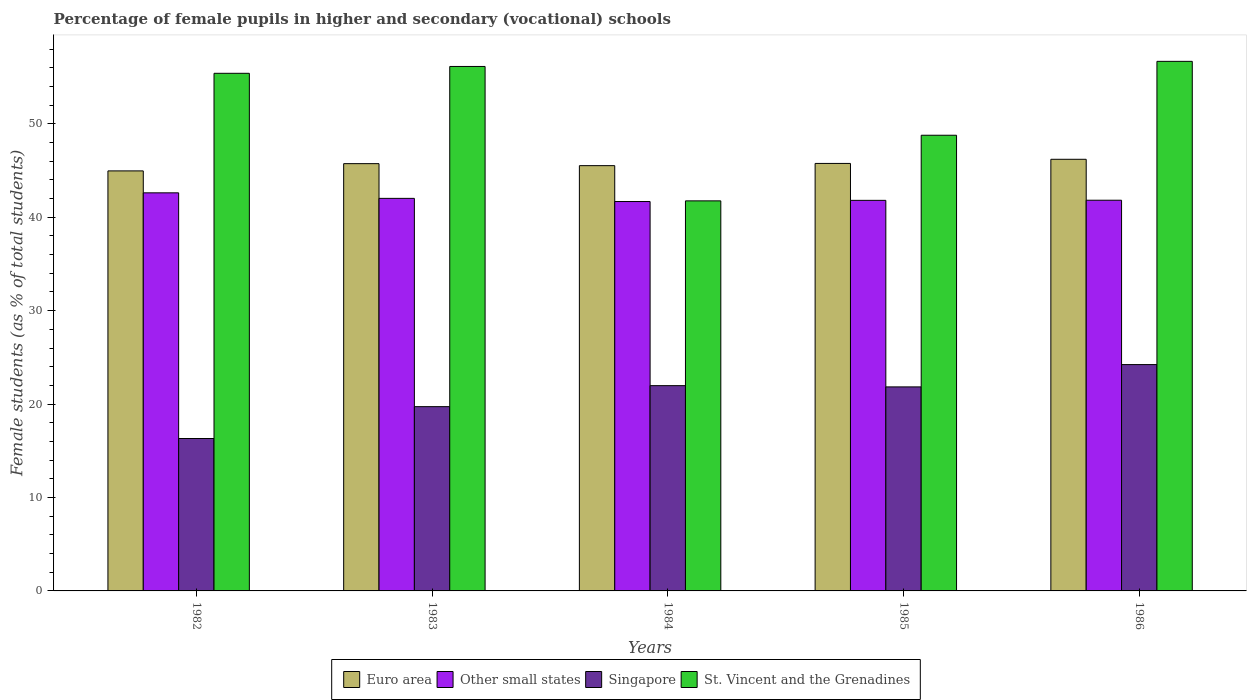How many groups of bars are there?
Your answer should be compact. 5. Are the number of bars on each tick of the X-axis equal?
Offer a terse response. Yes. How many bars are there on the 4th tick from the right?
Give a very brief answer. 4. What is the label of the 1st group of bars from the left?
Make the answer very short. 1982. In how many cases, is the number of bars for a given year not equal to the number of legend labels?
Your answer should be very brief. 0. What is the percentage of female pupils in higher and secondary schools in Singapore in 1982?
Offer a very short reply. 16.31. Across all years, what is the maximum percentage of female pupils in higher and secondary schools in Other small states?
Offer a very short reply. 42.61. Across all years, what is the minimum percentage of female pupils in higher and secondary schools in Singapore?
Your answer should be very brief. 16.31. What is the total percentage of female pupils in higher and secondary schools in Euro area in the graph?
Offer a very short reply. 228.16. What is the difference between the percentage of female pupils in higher and secondary schools in St. Vincent and the Grenadines in 1982 and that in 1986?
Make the answer very short. -1.28. What is the difference between the percentage of female pupils in higher and secondary schools in St. Vincent and the Grenadines in 1985 and the percentage of female pupils in higher and secondary schools in Singapore in 1984?
Offer a very short reply. 26.8. What is the average percentage of female pupils in higher and secondary schools in St. Vincent and the Grenadines per year?
Provide a succinct answer. 51.75. In the year 1984, what is the difference between the percentage of female pupils in higher and secondary schools in Euro area and percentage of female pupils in higher and secondary schools in Other small states?
Your answer should be compact. 3.84. In how many years, is the percentage of female pupils in higher and secondary schools in Other small states greater than 22 %?
Keep it short and to the point. 5. What is the ratio of the percentage of female pupils in higher and secondary schools in Singapore in 1984 to that in 1985?
Offer a terse response. 1.01. What is the difference between the highest and the second highest percentage of female pupils in higher and secondary schools in Singapore?
Provide a short and direct response. 2.26. What is the difference between the highest and the lowest percentage of female pupils in higher and secondary schools in St. Vincent and the Grenadines?
Provide a short and direct response. 14.93. In how many years, is the percentage of female pupils in higher and secondary schools in St. Vincent and the Grenadines greater than the average percentage of female pupils in higher and secondary schools in St. Vincent and the Grenadines taken over all years?
Offer a very short reply. 3. Is it the case that in every year, the sum of the percentage of female pupils in higher and secondary schools in Other small states and percentage of female pupils in higher and secondary schools in Euro area is greater than the sum of percentage of female pupils in higher and secondary schools in St. Vincent and the Grenadines and percentage of female pupils in higher and secondary schools in Singapore?
Offer a very short reply. Yes. What does the 3rd bar from the left in 1986 represents?
Keep it short and to the point. Singapore. Is it the case that in every year, the sum of the percentage of female pupils in higher and secondary schools in St. Vincent and the Grenadines and percentage of female pupils in higher and secondary schools in Other small states is greater than the percentage of female pupils in higher and secondary schools in Singapore?
Offer a very short reply. Yes. How many bars are there?
Your response must be concise. 20. Are all the bars in the graph horizontal?
Give a very brief answer. No. Does the graph contain grids?
Keep it short and to the point. No. Where does the legend appear in the graph?
Your answer should be compact. Bottom center. How are the legend labels stacked?
Ensure brevity in your answer.  Horizontal. What is the title of the graph?
Provide a short and direct response. Percentage of female pupils in higher and secondary (vocational) schools. What is the label or title of the X-axis?
Make the answer very short. Years. What is the label or title of the Y-axis?
Give a very brief answer. Female students (as % of total students). What is the Female students (as % of total students) of Euro area in 1982?
Make the answer very short. 44.96. What is the Female students (as % of total students) in Other small states in 1982?
Provide a succinct answer. 42.61. What is the Female students (as % of total students) of Singapore in 1982?
Your answer should be compact. 16.31. What is the Female students (as % of total students) in St. Vincent and the Grenadines in 1982?
Ensure brevity in your answer.  55.4. What is the Female students (as % of total students) in Euro area in 1983?
Provide a short and direct response. 45.73. What is the Female students (as % of total students) in Other small states in 1983?
Ensure brevity in your answer.  42.02. What is the Female students (as % of total students) of Singapore in 1983?
Provide a short and direct response. 19.72. What is the Female students (as % of total students) of St. Vincent and the Grenadines in 1983?
Your response must be concise. 56.13. What is the Female students (as % of total students) of Euro area in 1984?
Provide a short and direct response. 45.52. What is the Female students (as % of total students) in Other small states in 1984?
Provide a short and direct response. 41.68. What is the Female students (as % of total students) in Singapore in 1984?
Keep it short and to the point. 21.97. What is the Female students (as % of total students) of St. Vincent and the Grenadines in 1984?
Your answer should be very brief. 41.75. What is the Female students (as % of total students) in Euro area in 1985?
Offer a terse response. 45.76. What is the Female students (as % of total students) in Other small states in 1985?
Give a very brief answer. 41.8. What is the Female students (as % of total students) in Singapore in 1985?
Provide a succinct answer. 21.84. What is the Female students (as % of total students) in St. Vincent and the Grenadines in 1985?
Your answer should be very brief. 48.77. What is the Female students (as % of total students) in Euro area in 1986?
Your answer should be compact. 46.2. What is the Female students (as % of total students) in Other small states in 1986?
Your answer should be very brief. 41.82. What is the Female students (as % of total students) of Singapore in 1986?
Your answer should be very brief. 24.23. What is the Female students (as % of total students) of St. Vincent and the Grenadines in 1986?
Keep it short and to the point. 56.68. Across all years, what is the maximum Female students (as % of total students) in Euro area?
Your answer should be compact. 46.2. Across all years, what is the maximum Female students (as % of total students) of Other small states?
Offer a terse response. 42.61. Across all years, what is the maximum Female students (as % of total students) of Singapore?
Give a very brief answer. 24.23. Across all years, what is the maximum Female students (as % of total students) in St. Vincent and the Grenadines?
Provide a short and direct response. 56.68. Across all years, what is the minimum Female students (as % of total students) of Euro area?
Your response must be concise. 44.96. Across all years, what is the minimum Female students (as % of total students) in Other small states?
Your response must be concise. 41.68. Across all years, what is the minimum Female students (as % of total students) in Singapore?
Offer a very short reply. 16.31. Across all years, what is the minimum Female students (as % of total students) in St. Vincent and the Grenadines?
Your answer should be very brief. 41.75. What is the total Female students (as % of total students) of Euro area in the graph?
Keep it short and to the point. 228.16. What is the total Female students (as % of total students) in Other small states in the graph?
Offer a very short reply. 209.92. What is the total Female students (as % of total students) of Singapore in the graph?
Provide a succinct answer. 104.07. What is the total Female students (as % of total students) of St. Vincent and the Grenadines in the graph?
Your answer should be very brief. 258.73. What is the difference between the Female students (as % of total students) in Euro area in 1982 and that in 1983?
Offer a very short reply. -0.78. What is the difference between the Female students (as % of total students) in Other small states in 1982 and that in 1983?
Keep it short and to the point. 0.59. What is the difference between the Female students (as % of total students) of Singapore in 1982 and that in 1983?
Your response must be concise. -3.41. What is the difference between the Female students (as % of total students) of St. Vincent and the Grenadines in 1982 and that in 1983?
Make the answer very short. -0.73. What is the difference between the Female students (as % of total students) in Euro area in 1982 and that in 1984?
Your answer should be compact. -0.56. What is the difference between the Female students (as % of total students) in Other small states in 1982 and that in 1984?
Your answer should be compact. 0.93. What is the difference between the Female students (as % of total students) of Singapore in 1982 and that in 1984?
Your answer should be very brief. -5.66. What is the difference between the Female students (as % of total students) of St. Vincent and the Grenadines in 1982 and that in 1984?
Make the answer very short. 13.65. What is the difference between the Female students (as % of total students) in Euro area in 1982 and that in 1985?
Offer a terse response. -0.8. What is the difference between the Female students (as % of total students) in Other small states in 1982 and that in 1985?
Provide a succinct answer. 0.8. What is the difference between the Female students (as % of total students) in Singapore in 1982 and that in 1985?
Keep it short and to the point. -5.52. What is the difference between the Female students (as % of total students) of St. Vincent and the Grenadines in 1982 and that in 1985?
Your answer should be very brief. 6.63. What is the difference between the Female students (as % of total students) of Euro area in 1982 and that in 1986?
Your answer should be compact. -1.24. What is the difference between the Female students (as % of total students) of Other small states in 1982 and that in 1986?
Offer a very short reply. 0.79. What is the difference between the Female students (as % of total students) of Singapore in 1982 and that in 1986?
Offer a terse response. -7.91. What is the difference between the Female students (as % of total students) of St. Vincent and the Grenadines in 1982 and that in 1986?
Your answer should be very brief. -1.28. What is the difference between the Female students (as % of total students) of Euro area in 1983 and that in 1984?
Your response must be concise. 0.21. What is the difference between the Female students (as % of total students) in Other small states in 1983 and that in 1984?
Your answer should be very brief. 0.34. What is the difference between the Female students (as % of total students) in Singapore in 1983 and that in 1984?
Offer a terse response. -2.25. What is the difference between the Female students (as % of total students) in St. Vincent and the Grenadines in 1983 and that in 1984?
Make the answer very short. 14.39. What is the difference between the Female students (as % of total students) of Euro area in 1983 and that in 1985?
Offer a very short reply. -0.02. What is the difference between the Female students (as % of total students) of Other small states in 1983 and that in 1985?
Offer a very short reply. 0.21. What is the difference between the Female students (as % of total students) in Singapore in 1983 and that in 1985?
Offer a very short reply. -2.11. What is the difference between the Female students (as % of total students) in St. Vincent and the Grenadines in 1983 and that in 1985?
Your response must be concise. 7.36. What is the difference between the Female students (as % of total students) in Euro area in 1983 and that in 1986?
Provide a short and direct response. -0.47. What is the difference between the Female students (as % of total students) in Other small states in 1983 and that in 1986?
Your answer should be very brief. 0.2. What is the difference between the Female students (as % of total students) of Singapore in 1983 and that in 1986?
Offer a terse response. -4.5. What is the difference between the Female students (as % of total students) of St. Vincent and the Grenadines in 1983 and that in 1986?
Ensure brevity in your answer.  -0.55. What is the difference between the Female students (as % of total students) in Euro area in 1984 and that in 1985?
Offer a terse response. -0.24. What is the difference between the Female students (as % of total students) of Other small states in 1984 and that in 1985?
Make the answer very short. -0.13. What is the difference between the Female students (as % of total students) of Singapore in 1984 and that in 1985?
Give a very brief answer. 0.13. What is the difference between the Female students (as % of total students) of St. Vincent and the Grenadines in 1984 and that in 1985?
Ensure brevity in your answer.  -7.02. What is the difference between the Female students (as % of total students) of Euro area in 1984 and that in 1986?
Your response must be concise. -0.68. What is the difference between the Female students (as % of total students) in Other small states in 1984 and that in 1986?
Your answer should be compact. -0.14. What is the difference between the Female students (as % of total students) of Singapore in 1984 and that in 1986?
Your answer should be very brief. -2.26. What is the difference between the Female students (as % of total students) of St. Vincent and the Grenadines in 1984 and that in 1986?
Offer a very short reply. -14.93. What is the difference between the Female students (as % of total students) of Euro area in 1985 and that in 1986?
Make the answer very short. -0.44. What is the difference between the Female students (as % of total students) in Other small states in 1985 and that in 1986?
Your answer should be compact. -0.01. What is the difference between the Female students (as % of total students) of Singapore in 1985 and that in 1986?
Offer a very short reply. -2.39. What is the difference between the Female students (as % of total students) in St. Vincent and the Grenadines in 1985 and that in 1986?
Ensure brevity in your answer.  -7.91. What is the difference between the Female students (as % of total students) in Euro area in 1982 and the Female students (as % of total students) in Other small states in 1983?
Provide a short and direct response. 2.94. What is the difference between the Female students (as % of total students) of Euro area in 1982 and the Female students (as % of total students) of Singapore in 1983?
Your answer should be compact. 25.23. What is the difference between the Female students (as % of total students) in Euro area in 1982 and the Female students (as % of total students) in St. Vincent and the Grenadines in 1983?
Provide a succinct answer. -11.18. What is the difference between the Female students (as % of total students) in Other small states in 1982 and the Female students (as % of total students) in Singapore in 1983?
Make the answer very short. 22.88. What is the difference between the Female students (as % of total students) of Other small states in 1982 and the Female students (as % of total students) of St. Vincent and the Grenadines in 1983?
Offer a terse response. -13.53. What is the difference between the Female students (as % of total students) of Singapore in 1982 and the Female students (as % of total students) of St. Vincent and the Grenadines in 1983?
Make the answer very short. -39.82. What is the difference between the Female students (as % of total students) of Euro area in 1982 and the Female students (as % of total students) of Other small states in 1984?
Provide a succinct answer. 3.28. What is the difference between the Female students (as % of total students) in Euro area in 1982 and the Female students (as % of total students) in Singapore in 1984?
Keep it short and to the point. 22.99. What is the difference between the Female students (as % of total students) of Euro area in 1982 and the Female students (as % of total students) of St. Vincent and the Grenadines in 1984?
Your answer should be very brief. 3.21. What is the difference between the Female students (as % of total students) of Other small states in 1982 and the Female students (as % of total students) of Singapore in 1984?
Make the answer very short. 20.64. What is the difference between the Female students (as % of total students) in Other small states in 1982 and the Female students (as % of total students) in St. Vincent and the Grenadines in 1984?
Offer a very short reply. 0.86. What is the difference between the Female students (as % of total students) of Singapore in 1982 and the Female students (as % of total students) of St. Vincent and the Grenadines in 1984?
Provide a succinct answer. -25.43. What is the difference between the Female students (as % of total students) of Euro area in 1982 and the Female students (as % of total students) of Other small states in 1985?
Your answer should be very brief. 3.15. What is the difference between the Female students (as % of total students) of Euro area in 1982 and the Female students (as % of total students) of Singapore in 1985?
Provide a succinct answer. 23.12. What is the difference between the Female students (as % of total students) of Euro area in 1982 and the Female students (as % of total students) of St. Vincent and the Grenadines in 1985?
Make the answer very short. -3.82. What is the difference between the Female students (as % of total students) in Other small states in 1982 and the Female students (as % of total students) in Singapore in 1985?
Your response must be concise. 20.77. What is the difference between the Female students (as % of total students) of Other small states in 1982 and the Female students (as % of total students) of St. Vincent and the Grenadines in 1985?
Your answer should be compact. -6.16. What is the difference between the Female students (as % of total students) of Singapore in 1982 and the Female students (as % of total students) of St. Vincent and the Grenadines in 1985?
Offer a very short reply. -32.46. What is the difference between the Female students (as % of total students) in Euro area in 1982 and the Female students (as % of total students) in Other small states in 1986?
Your answer should be very brief. 3.14. What is the difference between the Female students (as % of total students) in Euro area in 1982 and the Female students (as % of total students) in Singapore in 1986?
Provide a short and direct response. 20.73. What is the difference between the Female students (as % of total students) of Euro area in 1982 and the Female students (as % of total students) of St. Vincent and the Grenadines in 1986?
Offer a very short reply. -11.72. What is the difference between the Female students (as % of total students) of Other small states in 1982 and the Female students (as % of total students) of Singapore in 1986?
Your response must be concise. 18.38. What is the difference between the Female students (as % of total students) in Other small states in 1982 and the Female students (as % of total students) in St. Vincent and the Grenadines in 1986?
Provide a short and direct response. -14.07. What is the difference between the Female students (as % of total students) in Singapore in 1982 and the Female students (as % of total students) in St. Vincent and the Grenadines in 1986?
Your response must be concise. -40.37. What is the difference between the Female students (as % of total students) in Euro area in 1983 and the Female students (as % of total students) in Other small states in 1984?
Provide a succinct answer. 4.05. What is the difference between the Female students (as % of total students) in Euro area in 1983 and the Female students (as % of total students) in Singapore in 1984?
Your response must be concise. 23.76. What is the difference between the Female students (as % of total students) of Euro area in 1983 and the Female students (as % of total students) of St. Vincent and the Grenadines in 1984?
Your answer should be very brief. 3.98. What is the difference between the Female students (as % of total students) of Other small states in 1983 and the Female students (as % of total students) of Singapore in 1984?
Your answer should be compact. 20.05. What is the difference between the Female students (as % of total students) in Other small states in 1983 and the Female students (as % of total students) in St. Vincent and the Grenadines in 1984?
Offer a terse response. 0.27. What is the difference between the Female students (as % of total students) in Singapore in 1983 and the Female students (as % of total students) in St. Vincent and the Grenadines in 1984?
Ensure brevity in your answer.  -22.02. What is the difference between the Female students (as % of total students) in Euro area in 1983 and the Female students (as % of total students) in Other small states in 1985?
Your answer should be very brief. 3.93. What is the difference between the Female students (as % of total students) of Euro area in 1983 and the Female students (as % of total students) of Singapore in 1985?
Keep it short and to the point. 23.89. What is the difference between the Female students (as % of total students) in Euro area in 1983 and the Female students (as % of total students) in St. Vincent and the Grenadines in 1985?
Provide a succinct answer. -3.04. What is the difference between the Female students (as % of total students) of Other small states in 1983 and the Female students (as % of total students) of Singapore in 1985?
Provide a succinct answer. 20.18. What is the difference between the Female students (as % of total students) in Other small states in 1983 and the Female students (as % of total students) in St. Vincent and the Grenadines in 1985?
Give a very brief answer. -6.76. What is the difference between the Female students (as % of total students) in Singapore in 1983 and the Female students (as % of total students) in St. Vincent and the Grenadines in 1985?
Give a very brief answer. -29.05. What is the difference between the Female students (as % of total students) of Euro area in 1983 and the Female students (as % of total students) of Other small states in 1986?
Provide a short and direct response. 3.92. What is the difference between the Female students (as % of total students) in Euro area in 1983 and the Female students (as % of total students) in Singapore in 1986?
Keep it short and to the point. 21.51. What is the difference between the Female students (as % of total students) in Euro area in 1983 and the Female students (as % of total students) in St. Vincent and the Grenadines in 1986?
Offer a terse response. -10.95. What is the difference between the Female students (as % of total students) in Other small states in 1983 and the Female students (as % of total students) in Singapore in 1986?
Offer a terse response. 17.79. What is the difference between the Female students (as % of total students) of Other small states in 1983 and the Female students (as % of total students) of St. Vincent and the Grenadines in 1986?
Your response must be concise. -14.66. What is the difference between the Female students (as % of total students) of Singapore in 1983 and the Female students (as % of total students) of St. Vincent and the Grenadines in 1986?
Give a very brief answer. -36.96. What is the difference between the Female students (as % of total students) in Euro area in 1984 and the Female students (as % of total students) in Other small states in 1985?
Provide a succinct answer. 3.71. What is the difference between the Female students (as % of total students) of Euro area in 1984 and the Female students (as % of total students) of Singapore in 1985?
Your answer should be compact. 23.68. What is the difference between the Female students (as % of total students) in Euro area in 1984 and the Female students (as % of total students) in St. Vincent and the Grenadines in 1985?
Offer a terse response. -3.25. What is the difference between the Female students (as % of total students) of Other small states in 1984 and the Female students (as % of total students) of Singapore in 1985?
Your answer should be compact. 19.84. What is the difference between the Female students (as % of total students) of Other small states in 1984 and the Female students (as % of total students) of St. Vincent and the Grenadines in 1985?
Your response must be concise. -7.09. What is the difference between the Female students (as % of total students) of Singapore in 1984 and the Female students (as % of total students) of St. Vincent and the Grenadines in 1985?
Offer a terse response. -26.8. What is the difference between the Female students (as % of total students) of Euro area in 1984 and the Female students (as % of total students) of Other small states in 1986?
Offer a terse response. 3.7. What is the difference between the Female students (as % of total students) of Euro area in 1984 and the Female students (as % of total students) of Singapore in 1986?
Your response must be concise. 21.29. What is the difference between the Female students (as % of total students) of Euro area in 1984 and the Female students (as % of total students) of St. Vincent and the Grenadines in 1986?
Provide a succinct answer. -11.16. What is the difference between the Female students (as % of total students) in Other small states in 1984 and the Female students (as % of total students) in Singapore in 1986?
Give a very brief answer. 17.45. What is the difference between the Female students (as % of total students) in Other small states in 1984 and the Female students (as % of total students) in St. Vincent and the Grenadines in 1986?
Give a very brief answer. -15. What is the difference between the Female students (as % of total students) of Singapore in 1984 and the Female students (as % of total students) of St. Vincent and the Grenadines in 1986?
Keep it short and to the point. -34.71. What is the difference between the Female students (as % of total students) of Euro area in 1985 and the Female students (as % of total students) of Other small states in 1986?
Provide a succinct answer. 3.94. What is the difference between the Female students (as % of total students) of Euro area in 1985 and the Female students (as % of total students) of Singapore in 1986?
Make the answer very short. 21.53. What is the difference between the Female students (as % of total students) of Euro area in 1985 and the Female students (as % of total students) of St. Vincent and the Grenadines in 1986?
Your answer should be compact. -10.92. What is the difference between the Female students (as % of total students) in Other small states in 1985 and the Female students (as % of total students) in Singapore in 1986?
Your response must be concise. 17.58. What is the difference between the Female students (as % of total students) in Other small states in 1985 and the Female students (as % of total students) in St. Vincent and the Grenadines in 1986?
Offer a very short reply. -14.88. What is the difference between the Female students (as % of total students) in Singapore in 1985 and the Female students (as % of total students) in St. Vincent and the Grenadines in 1986?
Keep it short and to the point. -34.84. What is the average Female students (as % of total students) of Euro area per year?
Keep it short and to the point. 45.63. What is the average Female students (as % of total students) of Other small states per year?
Your answer should be compact. 41.98. What is the average Female students (as % of total students) in Singapore per year?
Offer a terse response. 20.81. What is the average Female students (as % of total students) of St. Vincent and the Grenadines per year?
Your response must be concise. 51.75. In the year 1982, what is the difference between the Female students (as % of total students) in Euro area and Female students (as % of total students) in Other small states?
Provide a succinct answer. 2.35. In the year 1982, what is the difference between the Female students (as % of total students) in Euro area and Female students (as % of total students) in Singapore?
Make the answer very short. 28.64. In the year 1982, what is the difference between the Female students (as % of total students) of Euro area and Female students (as % of total students) of St. Vincent and the Grenadines?
Provide a short and direct response. -10.44. In the year 1982, what is the difference between the Female students (as % of total students) of Other small states and Female students (as % of total students) of Singapore?
Provide a short and direct response. 26.29. In the year 1982, what is the difference between the Female students (as % of total students) in Other small states and Female students (as % of total students) in St. Vincent and the Grenadines?
Your response must be concise. -12.79. In the year 1982, what is the difference between the Female students (as % of total students) in Singapore and Female students (as % of total students) in St. Vincent and the Grenadines?
Make the answer very short. -39.09. In the year 1983, what is the difference between the Female students (as % of total students) in Euro area and Female students (as % of total students) in Other small states?
Your answer should be compact. 3.72. In the year 1983, what is the difference between the Female students (as % of total students) in Euro area and Female students (as % of total students) in Singapore?
Your answer should be very brief. 26.01. In the year 1983, what is the difference between the Female students (as % of total students) of Euro area and Female students (as % of total students) of St. Vincent and the Grenadines?
Keep it short and to the point. -10.4. In the year 1983, what is the difference between the Female students (as % of total students) in Other small states and Female students (as % of total students) in Singapore?
Offer a very short reply. 22.29. In the year 1983, what is the difference between the Female students (as % of total students) in Other small states and Female students (as % of total students) in St. Vincent and the Grenadines?
Offer a terse response. -14.12. In the year 1983, what is the difference between the Female students (as % of total students) in Singapore and Female students (as % of total students) in St. Vincent and the Grenadines?
Keep it short and to the point. -36.41. In the year 1984, what is the difference between the Female students (as % of total students) of Euro area and Female students (as % of total students) of Other small states?
Your response must be concise. 3.84. In the year 1984, what is the difference between the Female students (as % of total students) in Euro area and Female students (as % of total students) in Singapore?
Keep it short and to the point. 23.55. In the year 1984, what is the difference between the Female students (as % of total students) of Euro area and Female students (as % of total students) of St. Vincent and the Grenadines?
Your answer should be compact. 3.77. In the year 1984, what is the difference between the Female students (as % of total students) of Other small states and Female students (as % of total students) of Singapore?
Your answer should be very brief. 19.71. In the year 1984, what is the difference between the Female students (as % of total students) of Other small states and Female students (as % of total students) of St. Vincent and the Grenadines?
Offer a very short reply. -0.07. In the year 1984, what is the difference between the Female students (as % of total students) of Singapore and Female students (as % of total students) of St. Vincent and the Grenadines?
Offer a very short reply. -19.78. In the year 1985, what is the difference between the Female students (as % of total students) in Euro area and Female students (as % of total students) in Other small states?
Your response must be concise. 3.95. In the year 1985, what is the difference between the Female students (as % of total students) of Euro area and Female students (as % of total students) of Singapore?
Your answer should be compact. 23.92. In the year 1985, what is the difference between the Female students (as % of total students) in Euro area and Female students (as % of total students) in St. Vincent and the Grenadines?
Your response must be concise. -3.02. In the year 1985, what is the difference between the Female students (as % of total students) of Other small states and Female students (as % of total students) of Singapore?
Your response must be concise. 19.97. In the year 1985, what is the difference between the Female students (as % of total students) in Other small states and Female students (as % of total students) in St. Vincent and the Grenadines?
Provide a short and direct response. -6.97. In the year 1985, what is the difference between the Female students (as % of total students) in Singapore and Female students (as % of total students) in St. Vincent and the Grenadines?
Offer a very short reply. -26.93. In the year 1986, what is the difference between the Female students (as % of total students) in Euro area and Female students (as % of total students) in Other small states?
Make the answer very short. 4.38. In the year 1986, what is the difference between the Female students (as % of total students) of Euro area and Female students (as % of total students) of Singapore?
Your answer should be compact. 21.97. In the year 1986, what is the difference between the Female students (as % of total students) of Euro area and Female students (as % of total students) of St. Vincent and the Grenadines?
Keep it short and to the point. -10.48. In the year 1986, what is the difference between the Female students (as % of total students) of Other small states and Female students (as % of total students) of Singapore?
Your answer should be very brief. 17.59. In the year 1986, what is the difference between the Female students (as % of total students) in Other small states and Female students (as % of total students) in St. Vincent and the Grenadines?
Ensure brevity in your answer.  -14.86. In the year 1986, what is the difference between the Female students (as % of total students) of Singapore and Female students (as % of total students) of St. Vincent and the Grenadines?
Keep it short and to the point. -32.45. What is the ratio of the Female students (as % of total students) of Other small states in 1982 to that in 1983?
Offer a terse response. 1.01. What is the ratio of the Female students (as % of total students) of Singapore in 1982 to that in 1983?
Your response must be concise. 0.83. What is the ratio of the Female students (as % of total students) of St. Vincent and the Grenadines in 1982 to that in 1983?
Provide a short and direct response. 0.99. What is the ratio of the Female students (as % of total students) in Other small states in 1982 to that in 1984?
Ensure brevity in your answer.  1.02. What is the ratio of the Female students (as % of total students) in Singapore in 1982 to that in 1984?
Provide a succinct answer. 0.74. What is the ratio of the Female students (as % of total students) of St. Vincent and the Grenadines in 1982 to that in 1984?
Provide a succinct answer. 1.33. What is the ratio of the Female students (as % of total students) in Euro area in 1982 to that in 1985?
Keep it short and to the point. 0.98. What is the ratio of the Female students (as % of total students) in Other small states in 1982 to that in 1985?
Provide a succinct answer. 1.02. What is the ratio of the Female students (as % of total students) of Singapore in 1982 to that in 1985?
Your answer should be very brief. 0.75. What is the ratio of the Female students (as % of total students) in St. Vincent and the Grenadines in 1982 to that in 1985?
Give a very brief answer. 1.14. What is the ratio of the Female students (as % of total students) in Euro area in 1982 to that in 1986?
Your answer should be compact. 0.97. What is the ratio of the Female students (as % of total students) of Other small states in 1982 to that in 1986?
Your answer should be compact. 1.02. What is the ratio of the Female students (as % of total students) in Singapore in 1982 to that in 1986?
Keep it short and to the point. 0.67. What is the ratio of the Female students (as % of total students) in St. Vincent and the Grenadines in 1982 to that in 1986?
Offer a very short reply. 0.98. What is the ratio of the Female students (as % of total students) in Euro area in 1983 to that in 1984?
Ensure brevity in your answer.  1. What is the ratio of the Female students (as % of total students) of Other small states in 1983 to that in 1984?
Keep it short and to the point. 1.01. What is the ratio of the Female students (as % of total students) in Singapore in 1983 to that in 1984?
Provide a succinct answer. 0.9. What is the ratio of the Female students (as % of total students) of St. Vincent and the Grenadines in 1983 to that in 1984?
Keep it short and to the point. 1.34. What is the ratio of the Female students (as % of total students) of Singapore in 1983 to that in 1985?
Your answer should be compact. 0.9. What is the ratio of the Female students (as % of total students) of St. Vincent and the Grenadines in 1983 to that in 1985?
Provide a short and direct response. 1.15. What is the ratio of the Female students (as % of total students) of Singapore in 1983 to that in 1986?
Keep it short and to the point. 0.81. What is the ratio of the Female students (as % of total students) in Euro area in 1984 to that in 1985?
Ensure brevity in your answer.  0.99. What is the ratio of the Female students (as % of total students) of Singapore in 1984 to that in 1985?
Keep it short and to the point. 1.01. What is the ratio of the Female students (as % of total students) in St. Vincent and the Grenadines in 1984 to that in 1985?
Your answer should be very brief. 0.86. What is the ratio of the Female students (as % of total students) of Euro area in 1984 to that in 1986?
Offer a very short reply. 0.99. What is the ratio of the Female students (as % of total students) in Singapore in 1984 to that in 1986?
Ensure brevity in your answer.  0.91. What is the ratio of the Female students (as % of total students) of St. Vincent and the Grenadines in 1984 to that in 1986?
Make the answer very short. 0.74. What is the ratio of the Female students (as % of total students) of Euro area in 1985 to that in 1986?
Ensure brevity in your answer.  0.99. What is the ratio of the Female students (as % of total students) in Singapore in 1985 to that in 1986?
Provide a short and direct response. 0.9. What is the ratio of the Female students (as % of total students) in St. Vincent and the Grenadines in 1985 to that in 1986?
Your answer should be very brief. 0.86. What is the difference between the highest and the second highest Female students (as % of total students) of Euro area?
Provide a succinct answer. 0.44. What is the difference between the highest and the second highest Female students (as % of total students) of Other small states?
Provide a succinct answer. 0.59. What is the difference between the highest and the second highest Female students (as % of total students) of Singapore?
Provide a succinct answer. 2.26. What is the difference between the highest and the second highest Female students (as % of total students) in St. Vincent and the Grenadines?
Ensure brevity in your answer.  0.55. What is the difference between the highest and the lowest Female students (as % of total students) of Euro area?
Your response must be concise. 1.24. What is the difference between the highest and the lowest Female students (as % of total students) of Other small states?
Make the answer very short. 0.93. What is the difference between the highest and the lowest Female students (as % of total students) of Singapore?
Your answer should be very brief. 7.91. What is the difference between the highest and the lowest Female students (as % of total students) in St. Vincent and the Grenadines?
Your answer should be very brief. 14.93. 